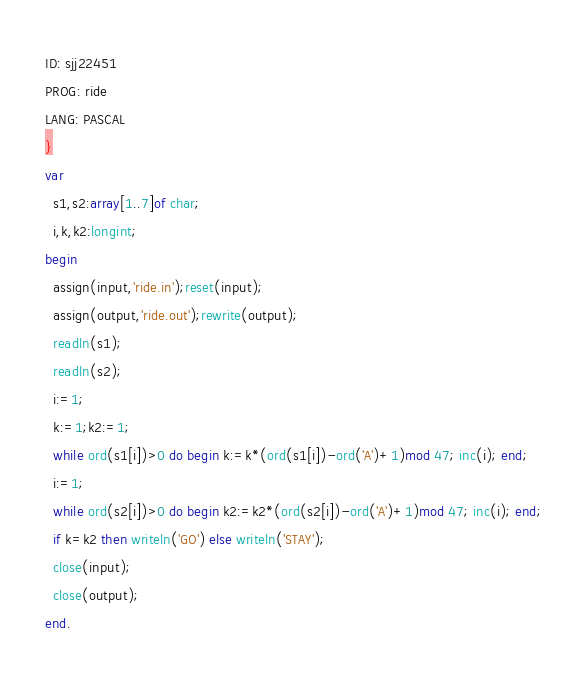<code> <loc_0><loc_0><loc_500><loc_500><_Pascal_>ID: sjj22451
PROG: ride
LANG: PASCAL
}
var
  s1,s2:array[1..7]of char;
  i,k,k2:longint;
begin
  assign(input,'ride.in');reset(input);
  assign(output,'ride.out');rewrite(output);
  readln(s1);
  readln(s2);
  i:=1;
  k:=1;k2:=1;
  while ord(s1[i])>0 do begin k:=k*(ord(s1[i])-ord('A')+1)mod 47; inc(i); end;
  i:=1;
  while ord(s2[i])>0 do begin k2:=k2*(ord(s2[i])-ord('A')+1)mod 47; inc(i); end;
  if k=k2 then writeln('GO') else writeln('STAY');
  close(input);
  close(output);
end.
</code> 